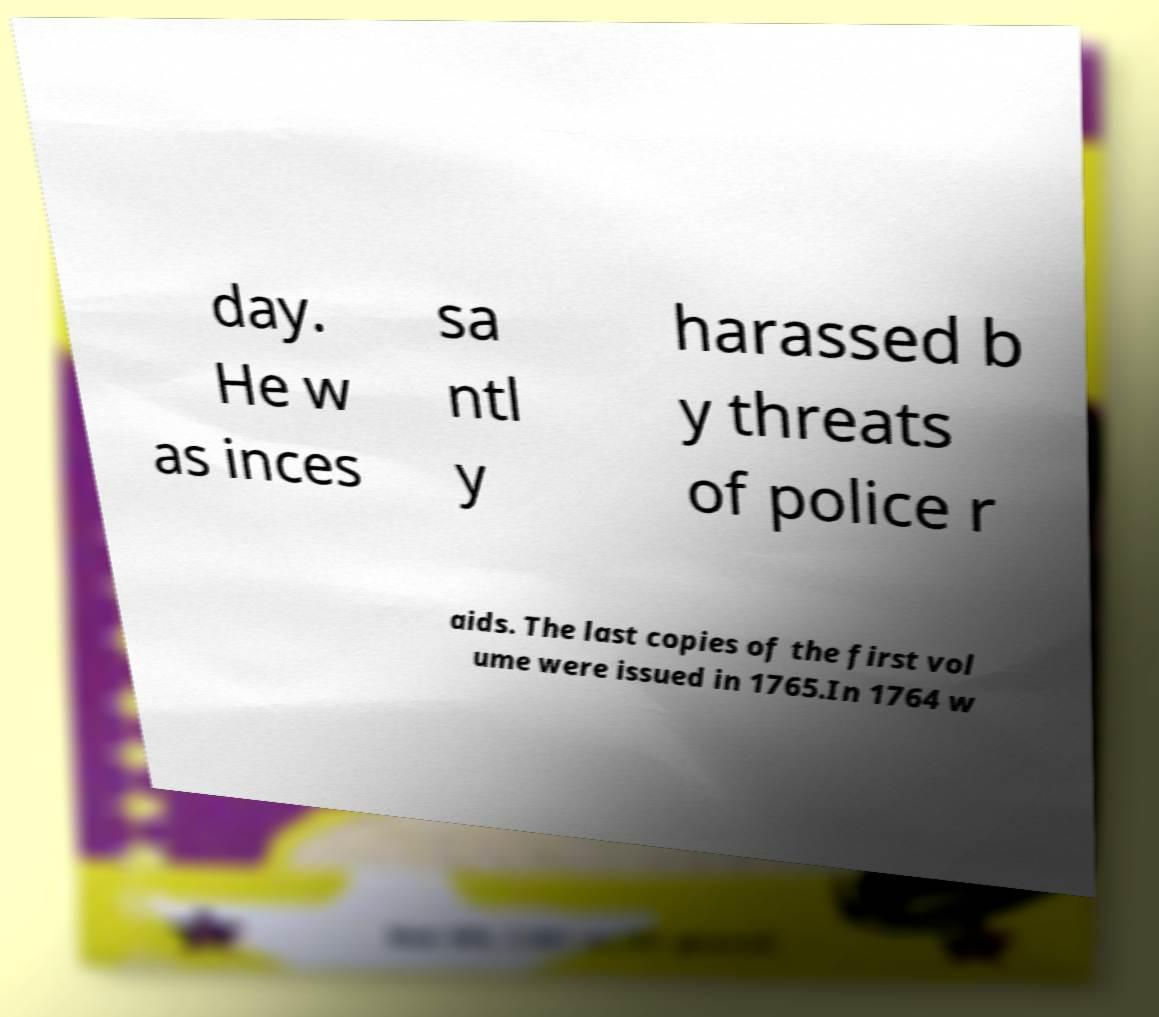Please read and relay the text visible in this image. What does it say? day. He w as inces sa ntl y harassed b y threats of police r aids. The last copies of the first vol ume were issued in 1765.In 1764 w 